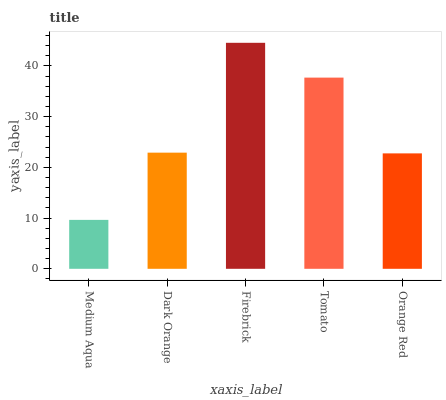Is Medium Aqua the minimum?
Answer yes or no. Yes. Is Firebrick the maximum?
Answer yes or no. Yes. Is Dark Orange the minimum?
Answer yes or no. No. Is Dark Orange the maximum?
Answer yes or no. No. Is Dark Orange greater than Medium Aqua?
Answer yes or no. Yes. Is Medium Aqua less than Dark Orange?
Answer yes or no. Yes. Is Medium Aqua greater than Dark Orange?
Answer yes or no. No. Is Dark Orange less than Medium Aqua?
Answer yes or no. No. Is Dark Orange the high median?
Answer yes or no. Yes. Is Dark Orange the low median?
Answer yes or no. Yes. Is Orange Red the high median?
Answer yes or no. No. Is Medium Aqua the low median?
Answer yes or no. No. 